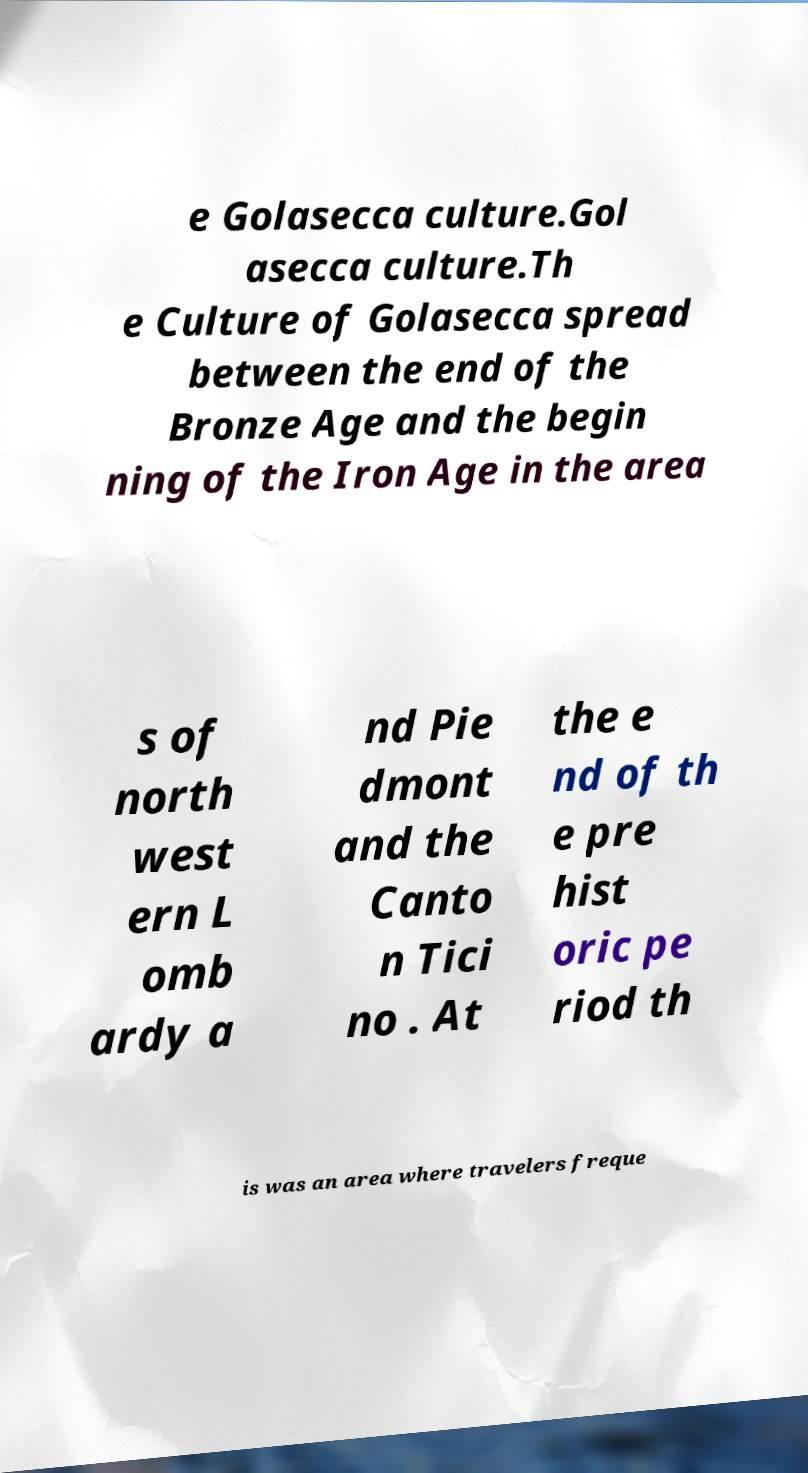Can you accurately transcribe the text from the provided image for me? e Golasecca culture.Gol asecca culture.Th e Culture of Golasecca spread between the end of the Bronze Age and the begin ning of the Iron Age in the area s of north west ern L omb ardy a nd Pie dmont and the Canto n Tici no . At the e nd of th e pre hist oric pe riod th is was an area where travelers freque 